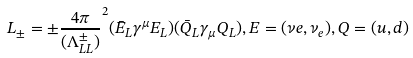<formula> <loc_0><loc_0><loc_500><loc_500>L _ { \pm } = \pm \frac { 4 \pi } { ( \Lambda _ { L L } ^ { \pm } ) } ^ { 2 } ( \bar { E } _ { L } \gamma ^ { \mu } E _ { L } ) ( \bar { Q } _ { L } \gamma _ { \mu } Q _ { L } ) , E = ( \nu e , \nu _ { e } ) , Q = ( u , d )</formula> 